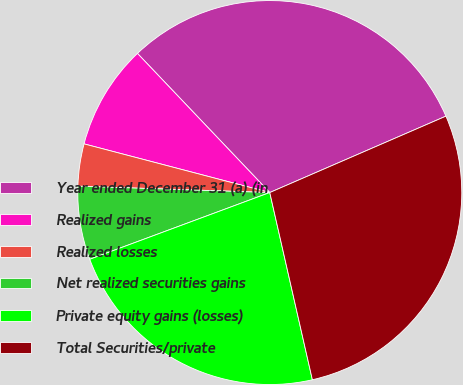Convert chart. <chart><loc_0><loc_0><loc_500><loc_500><pie_chart><fcel>Year ended December 31 (a) (in<fcel>Realized gains<fcel>Realized losses<fcel>Net realized securities gains<fcel>Private equity gains (losses)<fcel>Total Securities/private<nl><fcel>30.59%<fcel>8.82%<fcel>3.55%<fcel>6.18%<fcel>22.91%<fcel>27.95%<nl></chart> 